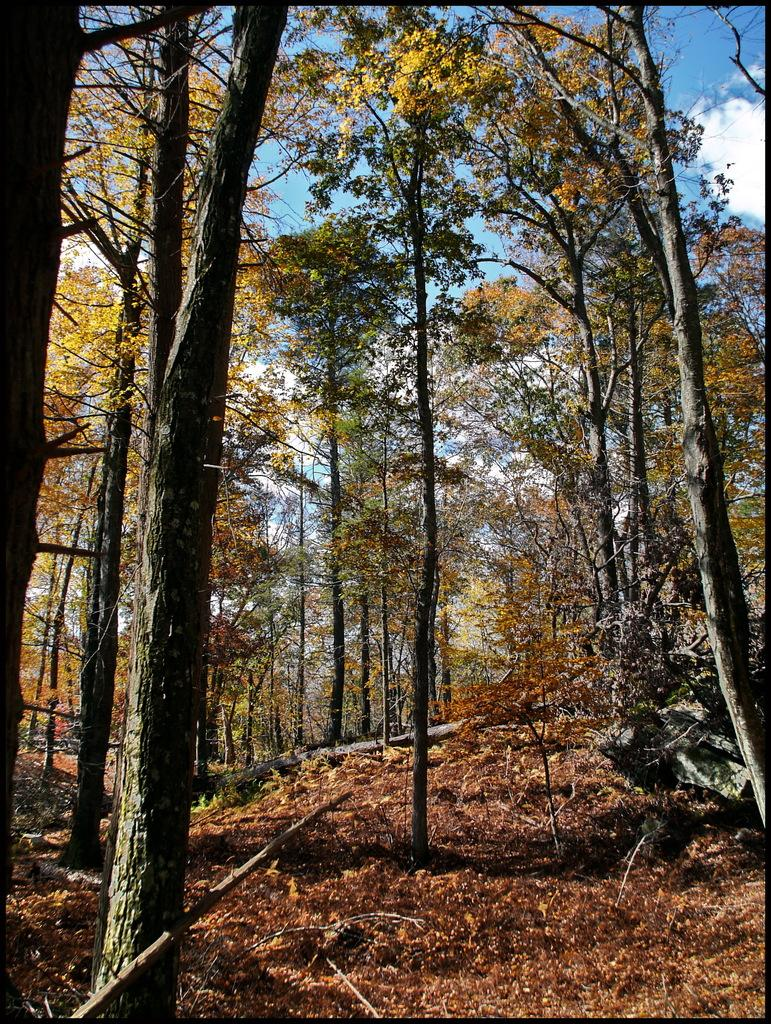What type of vegetation is present in the image? There are many trees in the image. What is on the ground beneath the trees? There are leaves on the ground in the image. What can be seen in the background of the image? There is a sky visible in the background of the image. What is the condition of the sky in the image? Clouds are present in the sky. What type of company is represented by the zebra in the image? There is no zebra present in the image, so it is not possible to determine the type of company it might represent. 